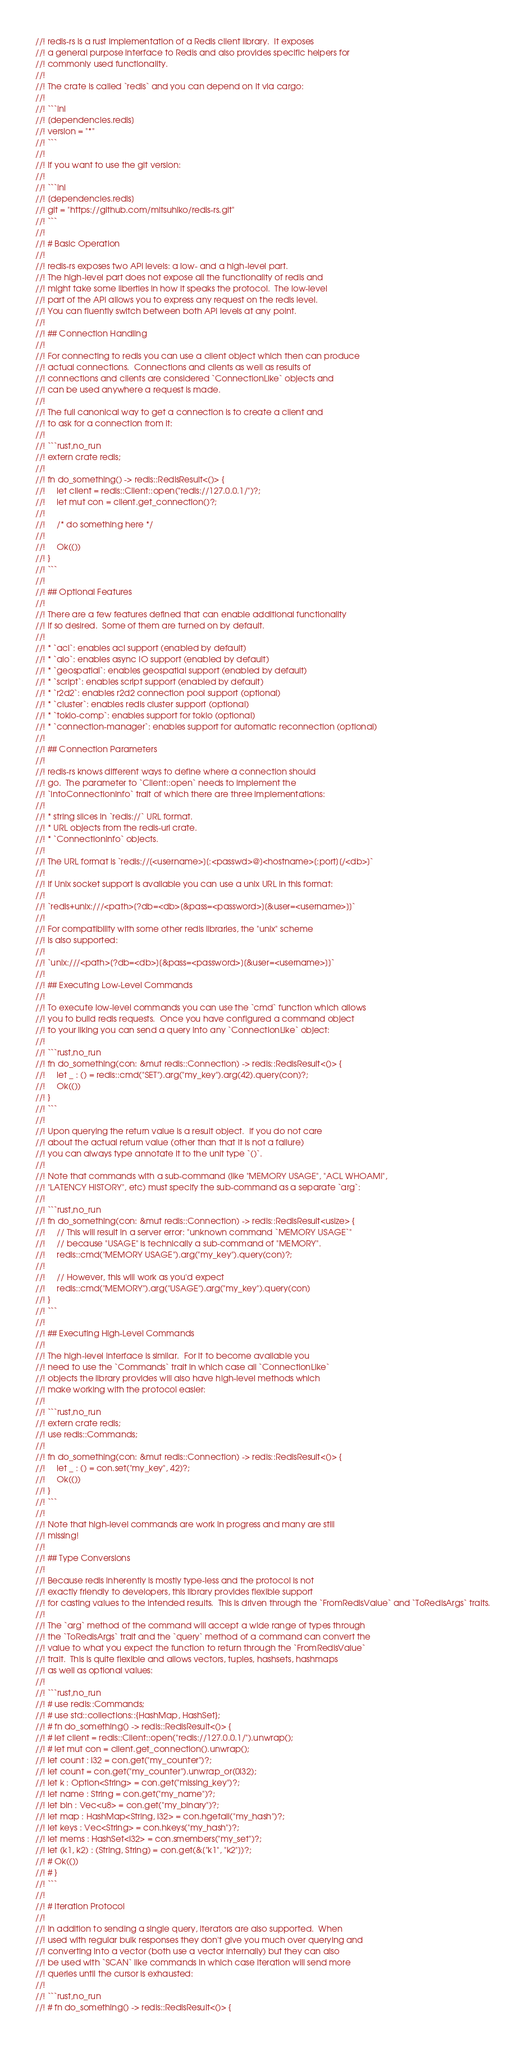<code> <loc_0><loc_0><loc_500><loc_500><_Rust_>//! redis-rs is a rust implementation of a Redis client library.  It exposes
//! a general purpose interface to Redis and also provides specific helpers for
//! commonly used functionality.
//!
//! The crate is called `redis` and you can depend on it via cargo:
//!
//! ```ini
//! [dependencies.redis]
//! version = "*"
//! ```
//!
//! If you want to use the git version:
//!
//! ```ini
//! [dependencies.redis]
//! git = "https://github.com/mitsuhiko/redis-rs.git"
//! ```
//!
//! # Basic Operation
//!
//! redis-rs exposes two API levels: a low- and a high-level part.
//! The high-level part does not expose all the functionality of redis and
//! might take some liberties in how it speaks the protocol.  The low-level
//! part of the API allows you to express any request on the redis level.
//! You can fluently switch between both API levels at any point.
//!
//! ## Connection Handling
//!
//! For connecting to redis you can use a client object which then can produce
//! actual connections.  Connections and clients as well as results of
//! connections and clients are considered `ConnectionLike` objects and
//! can be used anywhere a request is made.
//!
//! The full canonical way to get a connection is to create a client and
//! to ask for a connection from it:
//!
//! ```rust,no_run
//! extern crate redis;
//!
//! fn do_something() -> redis::RedisResult<()> {
//!     let client = redis::Client::open("redis://127.0.0.1/")?;
//!     let mut con = client.get_connection()?;
//!
//!     /* do something here */
//!
//!     Ok(())
//! }
//! ```
//!
//! ## Optional Features
//!
//! There are a few features defined that can enable additional functionality
//! if so desired.  Some of them are turned on by default.
//!
//! * `acl`: enables acl support (enabled by default)
//! * `aio`: enables async IO support (enabled by default)
//! * `geospatial`: enables geospatial support (enabled by default)
//! * `script`: enables script support (enabled by default)
//! * `r2d2`: enables r2d2 connection pool support (optional)
//! * `cluster`: enables redis cluster support (optional)
//! * `tokio-comp`: enables support for tokio (optional)
//! * `connection-manager`: enables support for automatic reconnection (optional)
//!
//! ## Connection Parameters
//!
//! redis-rs knows different ways to define where a connection should
//! go.  The parameter to `Client::open` needs to implement the
//! `IntoConnectionInfo` trait of which there are three implementations:
//!
//! * string slices in `redis://` URL format.
//! * URL objects from the redis-url crate.
//! * `ConnectionInfo` objects.
//!
//! The URL format is `redis://[<username>][:<passwd>@]<hostname>[:port][/<db>]`
//!
//! If Unix socket support is available you can use a unix URL in this format:
//!
//! `redis+unix:///<path>[?db=<db>[&pass=<password>][&user=<username>]]`
//!
//! For compatibility with some other redis libraries, the "unix" scheme
//! is also supported:
//!
//! `unix:///<path>[?db=<db>][&pass=<password>][&user=<username>]]`
//!
//! ## Executing Low-Level Commands
//!
//! To execute low-level commands you can use the `cmd` function which allows
//! you to build redis requests.  Once you have configured a command object
//! to your liking you can send a query into any `ConnectionLike` object:
//!
//! ```rust,no_run
//! fn do_something(con: &mut redis::Connection) -> redis::RedisResult<()> {
//!     let _ : () = redis::cmd("SET").arg("my_key").arg(42).query(con)?;
//!     Ok(())
//! }
//! ```
//!
//! Upon querying the return value is a result object.  If you do not care
//! about the actual return value (other than that it is not a failure)
//! you can always type annotate it to the unit type `()`.
//!
//! Note that commands with a sub-command (like "MEMORY USAGE", "ACL WHOAMI",
//! "LATENCY HISTORY", etc) must specify the sub-command as a separate `arg`:
//!
//! ```rust,no_run
//! fn do_something(con: &mut redis::Connection) -> redis::RedisResult<usize> {
//!     // This will result in a server error: "unknown command `MEMORY USAGE`"
//!     // because "USAGE" is technically a sub-command of "MEMORY".
//!     redis::cmd("MEMORY USAGE").arg("my_key").query(con)?;
//!
//!     // However, this will work as you'd expect
//!     redis::cmd("MEMORY").arg("USAGE").arg("my_key").query(con)
//! }
//! ```
//!
//! ## Executing High-Level Commands
//!
//! The high-level interface is similar.  For it to become available you
//! need to use the `Commands` trait in which case all `ConnectionLike`
//! objects the library provides will also have high-level methods which
//! make working with the protocol easier:
//!
//! ```rust,no_run
//! extern crate redis;
//! use redis::Commands;
//!
//! fn do_something(con: &mut redis::Connection) -> redis::RedisResult<()> {
//!     let _ : () = con.set("my_key", 42)?;
//!     Ok(())
//! }
//! ```
//!
//! Note that high-level commands are work in progress and many are still
//! missing!
//!
//! ## Type Conversions
//!
//! Because redis inherently is mostly type-less and the protocol is not
//! exactly friendly to developers, this library provides flexible support
//! for casting values to the intended results.  This is driven through the `FromRedisValue` and `ToRedisArgs` traits.
//!
//! The `arg` method of the command will accept a wide range of types through
//! the `ToRedisArgs` trait and the `query` method of a command can convert the
//! value to what you expect the function to return through the `FromRedisValue`
//! trait.  This is quite flexible and allows vectors, tuples, hashsets, hashmaps
//! as well as optional values:
//!
//! ```rust,no_run
//! # use redis::Commands;
//! # use std::collections::{HashMap, HashSet};
//! # fn do_something() -> redis::RedisResult<()> {
//! # let client = redis::Client::open("redis://127.0.0.1/").unwrap();
//! # let mut con = client.get_connection().unwrap();
//! let count : i32 = con.get("my_counter")?;
//! let count = con.get("my_counter").unwrap_or(0i32);
//! let k : Option<String> = con.get("missing_key")?;
//! let name : String = con.get("my_name")?;
//! let bin : Vec<u8> = con.get("my_binary")?;
//! let map : HashMap<String, i32> = con.hgetall("my_hash")?;
//! let keys : Vec<String> = con.hkeys("my_hash")?;
//! let mems : HashSet<i32> = con.smembers("my_set")?;
//! let (k1, k2) : (String, String) = con.get(&["k1", "k2"])?;
//! # Ok(())
//! # }
//! ```
//!
//! # Iteration Protocol
//!
//! In addition to sending a single query, iterators are also supported.  When
//! used with regular bulk responses they don't give you much over querying and
//! converting into a vector (both use a vector internally) but they can also
//! be used with `SCAN` like commands in which case iteration will send more
//! queries until the cursor is exhausted:
//!
//! ```rust,no_run
//! # fn do_something() -> redis::RedisResult<()> {</code> 